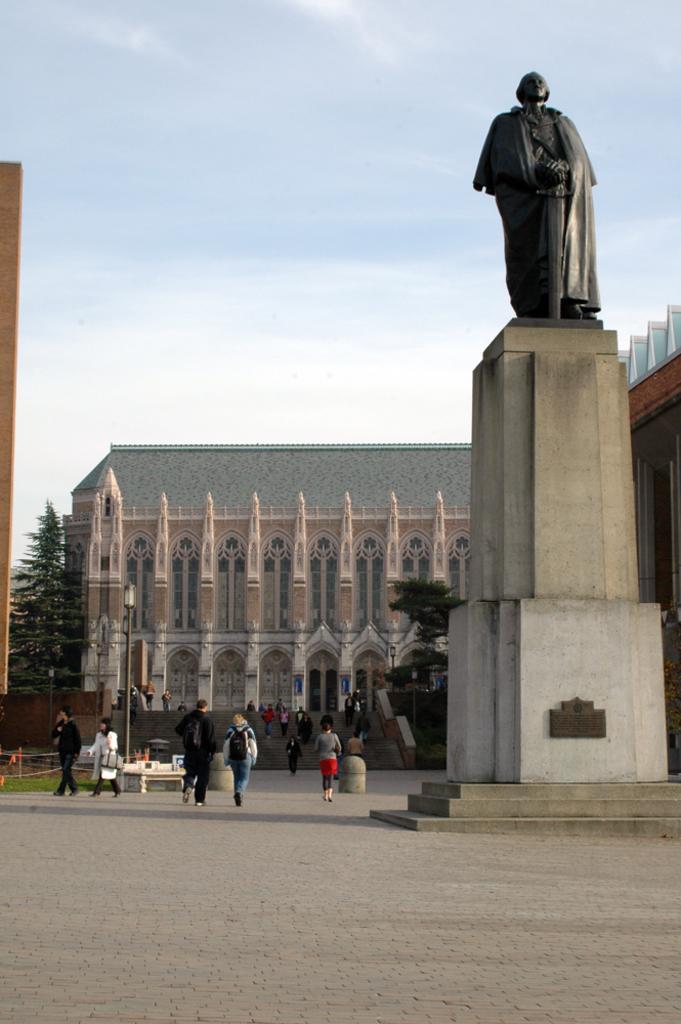Describe this image in one or two sentences. In the foreground of this image, on the right, there is a sculpture. On the left, there are persons walking on the pavement, a light pole, stairs, trees, buildings and the sky. 